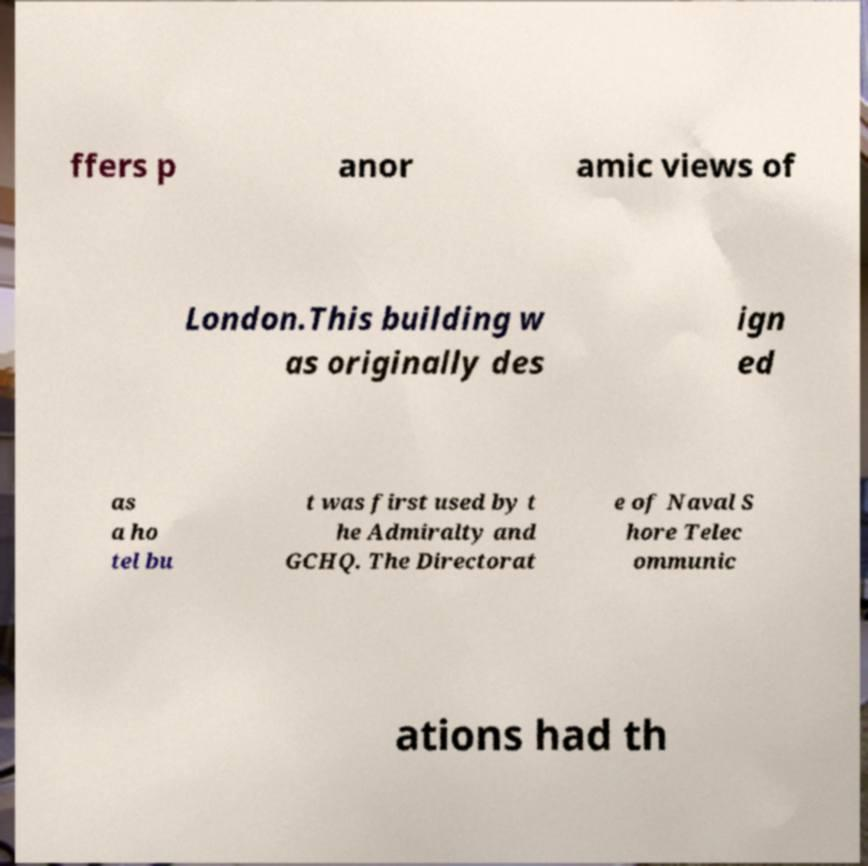Can you accurately transcribe the text from the provided image for me? ffers p anor amic views of London.This building w as originally des ign ed as a ho tel bu t was first used by t he Admiralty and GCHQ. The Directorat e of Naval S hore Telec ommunic ations had th 